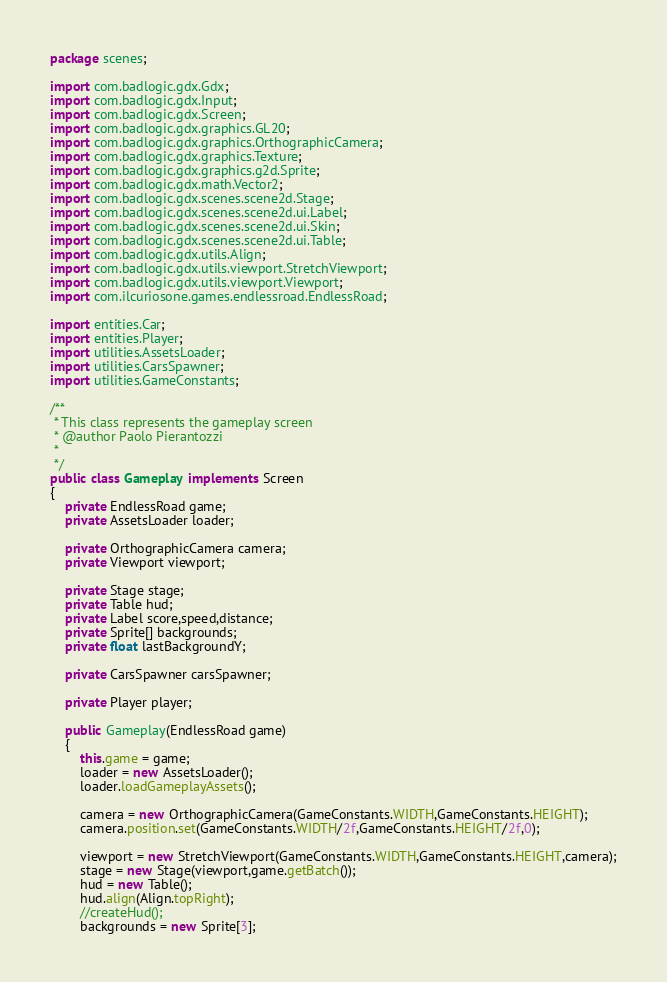<code> <loc_0><loc_0><loc_500><loc_500><_Java_>package scenes;

import com.badlogic.gdx.Gdx;
import com.badlogic.gdx.Input;
import com.badlogic.gdx.Screen;
import com.badlogic.gdx.graphics.GL20;
import com.badlogic.gdx.graphics.OrthographicCamera;
import com.badlogic.gdx.graphics.Texture;
import com.badlogic.gdx.graphics.g2d.Sprite;
import com.badlogic.gdx.math.Vector2;
import com.badlogic.gdx.scenes.scene2d.Stage;
import com.badlogic.gdx.scenes.scene2d.ui.Label;
import com.badlogic.gdx.scenes.scene2d.ui.Skin;
import com.badlogic.gdx.scenes.scene2d.ui.Table;
import com.badlogic.gdx.utils.Align;
import com.badlogic.gdx.utils.viewport.StretchViewport;
import com.badlogic.gdx.utils.viewport.Viewport;
import com.ilcuriosone.games.endlessroad.EndlessRoad;

import entities.Car;
import entities.Player;
import utilities.AssetsLoader;
import utilities.CarsSpawner;
import utilities.GameConstants;

/**
 * This class represents the gameplay screen
 * @author Paolo Pierantozzi
 *
 */
public class Gameplay implements Screen
{
	private EndlessRoad game;
	private AssetsLoader loader;
	
	private OrthographicCamera camera;
	private Viewport viewport;
	
	private Stage stage;
	private Table hud;
	private Label score,speed,distance;
	private Sprite[] backgrounds;
	private float lastBackgroundY;
	
	private CarsSpawner carsSpawner;	
	
	private Player player;
	
	public Gameplay(EndlessRoad game)
	{
		this.game = game;
		loader = new AssetsLoader();
		loader.loadGameplayAssets();
		
		camera = new OrthographicCamera(GameConstants.WIDTH,GameConstants.HEIGHT);
		camera.position.set(GameConstants.WIDTH/2f,GameConstants.HEIGHT/2f,0);
		
		viewport = new StretchViewport(GameConstants.WIDTH,GameConstants.HEIGHT,camera);
		stage = new Stage(viewport,game.getBatch());
		hud = new Table();
		hud.align(Align.topRight);
		//createHud();
		backgrounds = new Sprite[3];</code> 